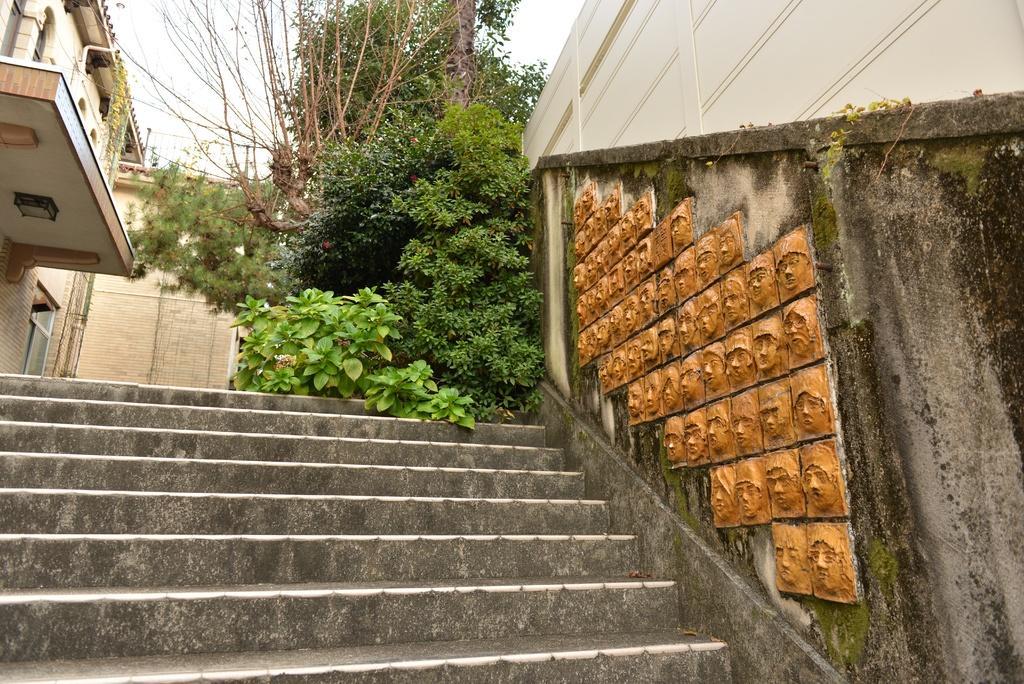Could you give a brief overview of what you see in this image? In front of the picture, we see the staircase. Beside that, we see a wall and the stone carved faces which are painted in yellow color. Behind that, we see a building in white color. In the middle, we see the trees. In the left top, we see the buildings. At the top, we see the sky. 